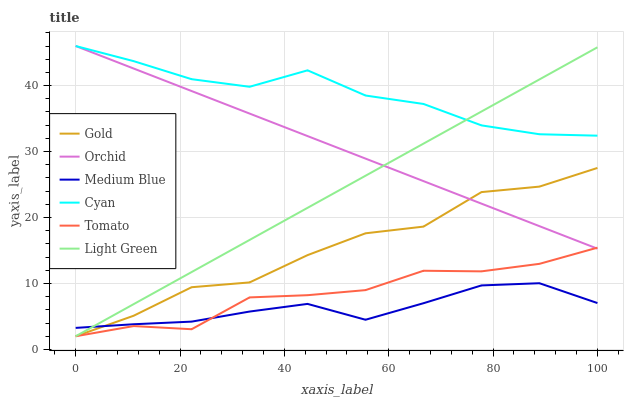Does Medium Blue have the minimum area under the curve?
Answer yes or no. Yes. Does Cyan have the maximum area under the curve?
Answer yes or no. Yes. Does Gold have the minimum area under the curve?
Answer yes or no. No. Does Gold have the maximum area under the curve?
Answer yes or no. No. Is Light Green the smoothest?
Answer yes or no. Yes. Is Gold the roughest?
Answer yes or no. Yes. Is Medium Blue the smoothest?
Answer yes or no. No. Is Medium Blue the roughest?
Answer yes or no. No. Does Tomato have the lowest value?
Answer yes or no. Yes. Does Medium Blue have the lowest value?
Answer yes or no. No. Does Orchid have the highest value?
Answer yes or no. Yes. Does Gold have the highest value?
Answer yes or no. No. Is Gold less than Cyan?
Answer yes or no. Yes. Is Cyan greater than Gold?
Answer yes or no. Yes. Does Light Green intersect Medium Blue?
Answer yes or no. Yes. Is Light Green less than Medium Blue?
Answer yes or no. No. Is Light Green greater than Medium Blue?
Answer yes or no. No. Does Gold intersect Cyan?
Answer yes or no. No. 